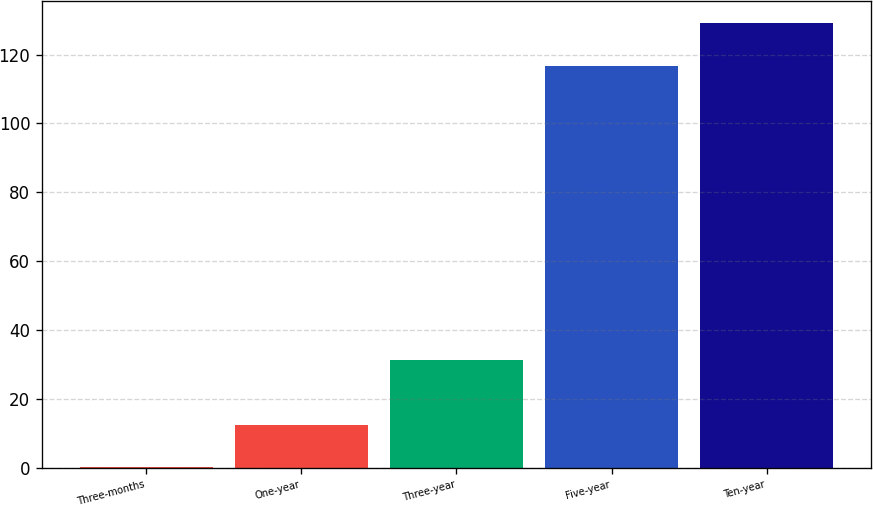<chart> <loc_0><loc_0><loc_500><loc_500><bar_chart><fcel>Three-months<fcel>One-year<fcel>Three-year<fcel>Five-year<fcel>Ten-year<nl><fcel>0.1<fcel>12.5<fcel>31.2<fcel>116.7<fcel>129.1<nl></chart> 